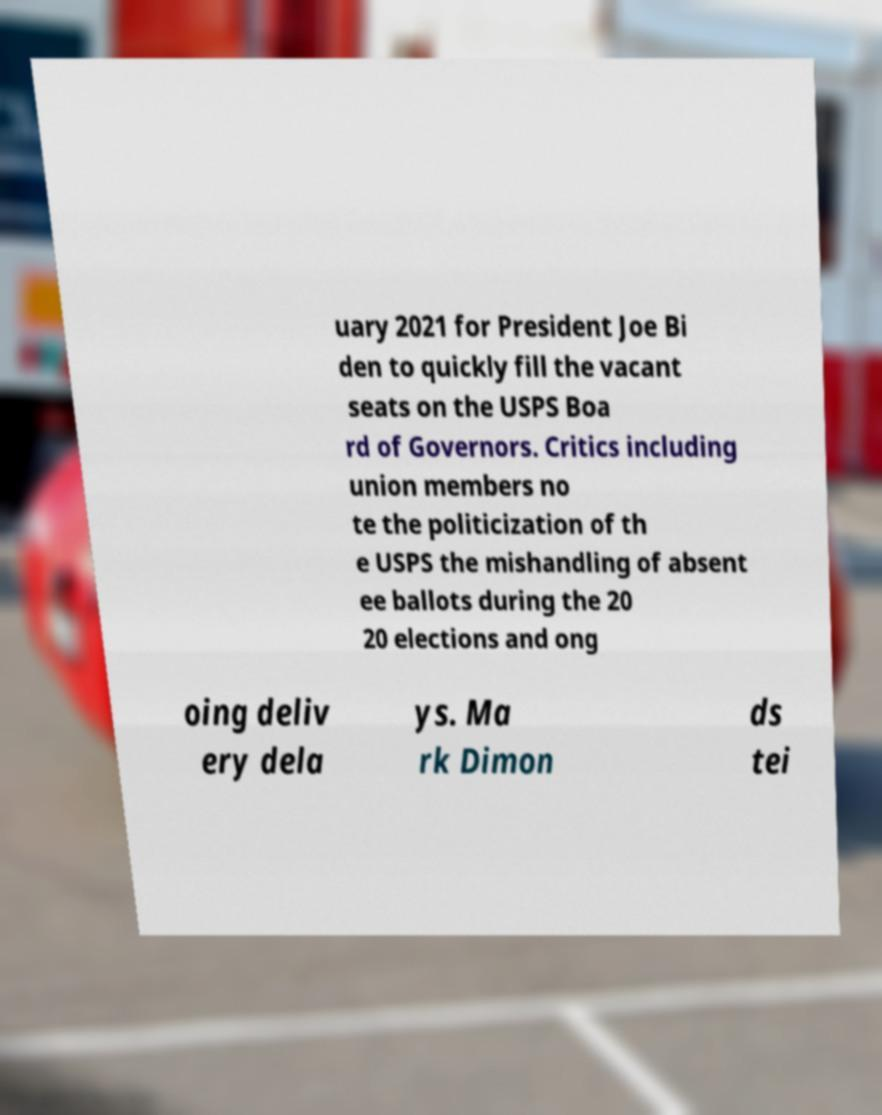What messages or text are displayed in this image? I need them in a readable, typed format. uary 2021 for President Joe Bi den to quickly fill the vacant seats on the USPS Boa rd of Governors. Critics including union members no te the politicization of th e USPS the mishandling of absent ee ballots during the 20 20 elections and ong oing deliv ery dela ys. Ma rk Dimon ds tei 